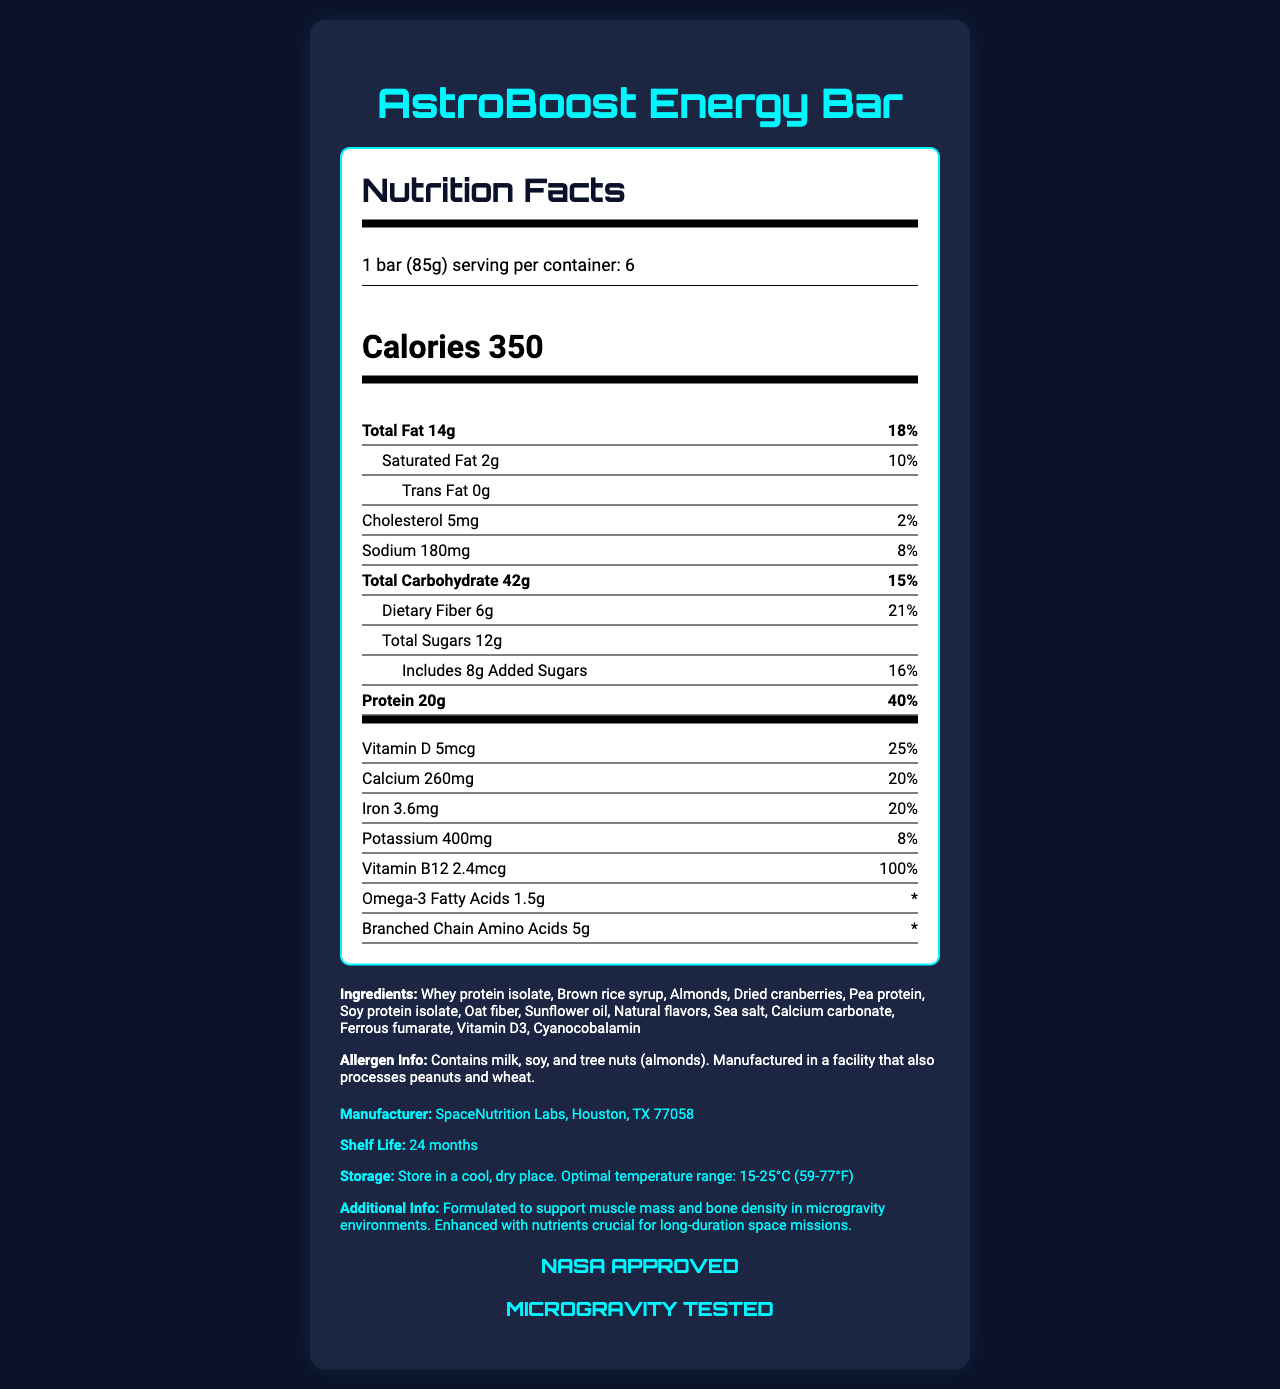what is the serving size for the AstroBoost Energy Bar? The serving size is explicitly stated as "1 bar (85g)" in the document.
Answer: 1 bar (85g) How many calories are in one serving of the AstroBoost Energy Bar? The number of calories per serving is stated directly in the nutrition facts.
Answer: 350 What is the total fat content per serving, and what percentage of the daily value does this represent? The document explicitly shows "Total Fat 14g" and the daily value percentage as "18%".
Answer: 14g, 18% what are the vitamin B12 content and its daily value percentage in the AstroBoost Energy Bar? The label lists Vitamin B12 with an amount of "2.4mcg" and a daily value of "100%".
Answer: 2.4mcg, 100% Does the product contain any allergens? If so, list them. The allergen information section specifically states that the product contains milk, soy, and tree nuts (almonds).
Answer: Yes, the product contains milk, soy, and tree nuts (almonds). Which facility manufactures the AstroBoost Energy Bar? The manufacturer information is clearly stated as "SpaceNutrition Labs, Houston, TX 77058".
Answer: SpaceNutrition Labs, Houston, TX 77058 What is the shelf life of the AstroBoost Energy Bar? The shelf life is mentioned as "24 months" in the document.
Answer: 24 months How much dietary fiber does each serving of the AstroBoost Energy Bar contain? The dietary fiber content per serving is listed as "6g."
Answer: 6g How much sodium is in one serving of the bar, and what is the daily value percentage? The sodium content is listed as "180mg" with a daily value percentage of "8%".
Answer: 180mg, 8% what is the additional info provided about the formulation of the AstroBoost Energy Bar? The additional information section describes the formulation to support muscle mass and bone density in microgravity environments and the enhancement with crucial nutrients for long-duration space missions.
Answer: Formulated to support muscle mass and bone density in microgravity environments. Enhanced with nutrients crucial for long-duration space missions. What is the primary ingredient in the AstroBoost Energy Bar? A. Almonds B. Whey protein isolate C. Dried cranberries D. Pea protein The first ingredient listed is "Whey protein isolate," making it the primary ingredient.
Answer: B Which of the following vitamins is present in the AstroBoost Energy Bar? A. Vitamin C B. Vitamin D3 C. Vitamin B6 D. Vitamin A The document lists Vitamin D3 as one of the vitamins included in the bar's ingredients.
Answer: B Is the AstroBoost Energy Bar NASA approved? The document explicitly states "NASA APPROVED" in the NASA approved section.
Answer: Yes Did the product undergo microgravity testing? The document clearly states "MICROGRAVITY TESTED."
Answer: Yes Summarize the key points of the AstroBoost Energy Bar Nutrition Facts label. The summary highlights the important nutrition facts, formulation purposes, NASA approval, storage instructions, and noteworthy details of the product.
Answer: The AstroBoost Energy Bar provides 350 calories per serving, with high protein content (20g, 40% DV) and significant fiber (6g, 21% DV). The label lists detailed nutrition facts, ingredients, allergen information, and manufacturer details. It is formulated to support muscle mass and bone density in microgravity environments, enhanced with crucial nutrients, and approved and tested by NASA. The shelf life is 24 months, and it should be stored in a cool, dry place. What is the specific amount of omega-3 fatty acids present in the product? The label lists "Omega-3 Fatty Acids 1.5g."
Answer: 1.5g Who is the target consumer group for the AstroBoost Energy Bar based on its formulation? The label specifies the formulation supports muscle mass and bone density in microgravity environments, but does not explicitly state the target consumer group.
Answer: Cannot be determined 